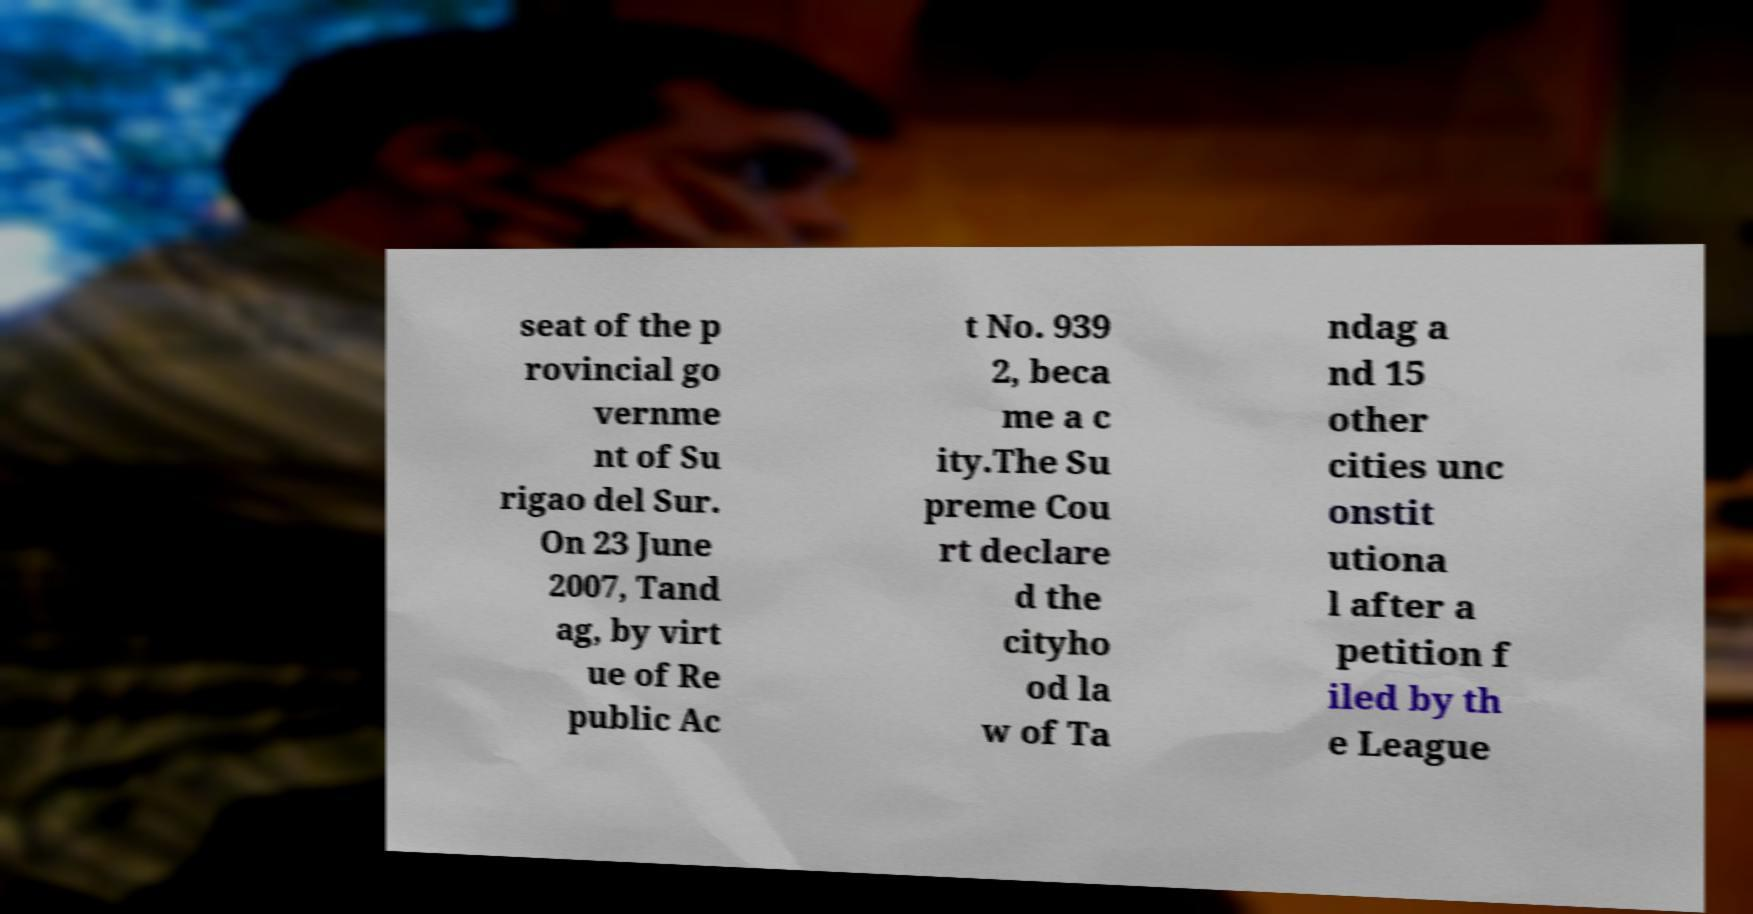For documentation purposes, I need the text within this image transcribed. Could you provide that? seat of the p rovincial go vernme nt of Su rigao del Sur. On 23 June 2007, Tand ag, by virt ue of Re public Ac t No. 939 2, beca me a c ity.The Su preme Cou rt declare d the cityho od la w of Ta ndag a nd 15 other cities unc onstit utiona l after a petition f iled by th e League 